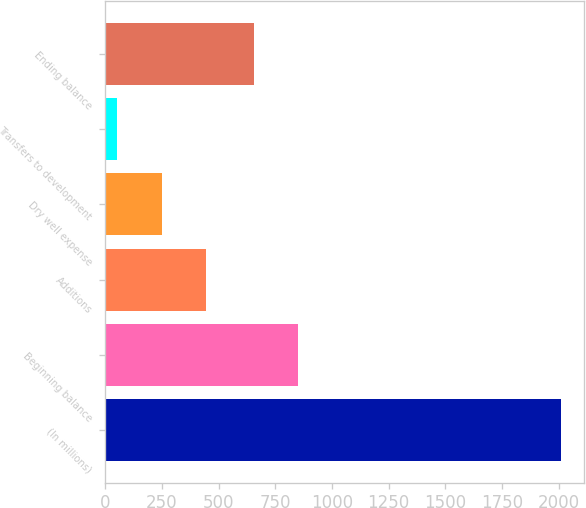Convert chart to OTSL. <chart><loc_0><loc_0><loc_500><loc_500><bar_chart><fcel>(In millions)<fcel>Beginning balance<fcel>Additions<fcel>Dry well expense<fcel>Transfers to development<fcel>Ending balance<nl><fcel>2010<fcel>852.6<fcel>445.2<fcel>249.6<fcel>54<fcel>657<nl></chart> 